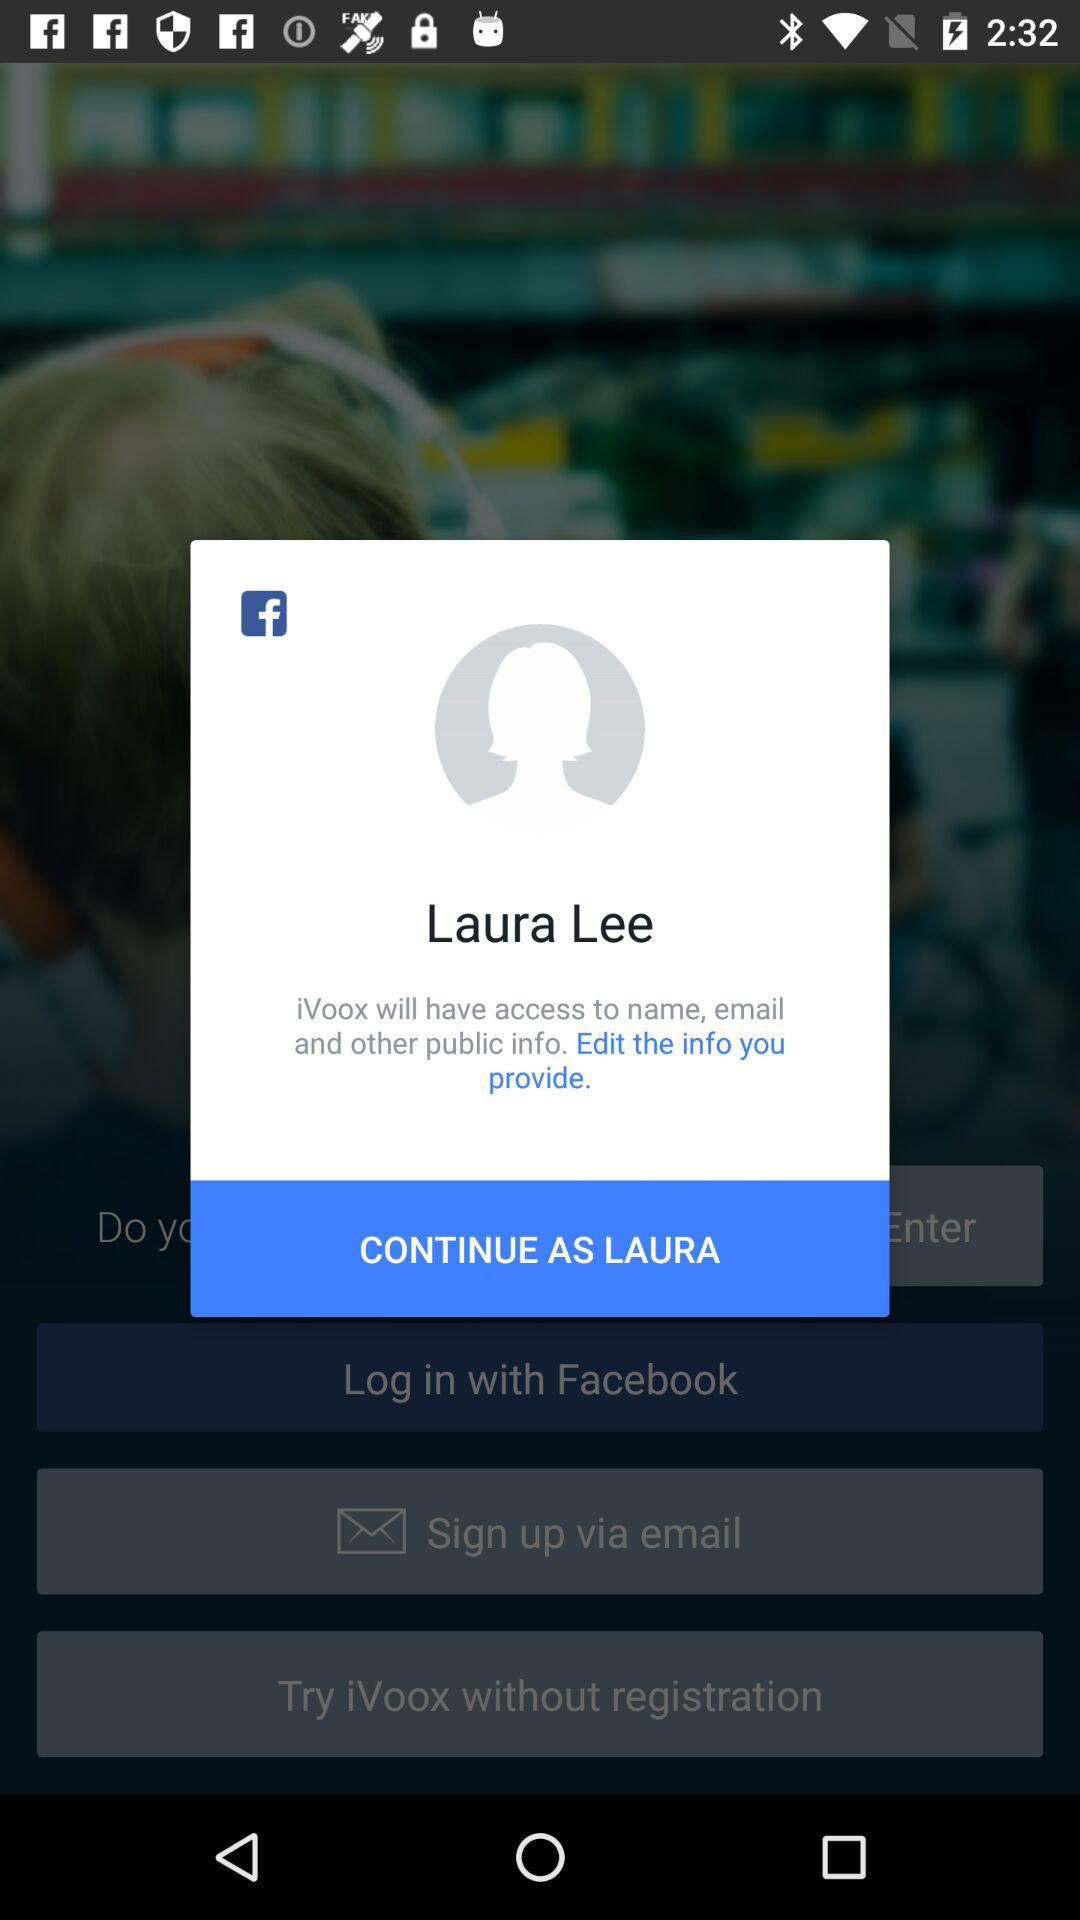What is the user name? The user name is Laura Lee. 